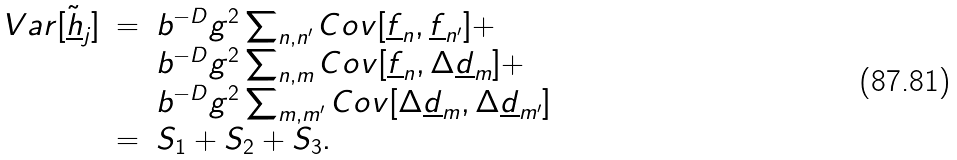<formula> <loc_0><loc_0><loc_500><loc_500>\begin{array} { l l l } V a r [ \underline { \tilde { h } } _ { j } ] & = & b ^ { - D } g ^ { 2 } \sum _ { n , n ^ { \prime } } C o v [ \underline { f } _ { n } , \underline { f } _ { n ^ { \prime } } ] + \\ & & b ^ { - D } g ^ { 2 } \sum _ { n , m } C o v [ \underline { f } _ { n } , \Delta \underline { d } _ { m } ] + \\ & & b ^ { - D } g ^ { 2 } \sum _ { m , m ^ { \prime } } C o v [ \Delta \underline { d } _ { m } , \Delta \underline { d } _ { m ^ { \prime } } ] \\ & = & S _ { 1 } + S _ { 2 } + S _ { 3 } . \end{array}</formula> 